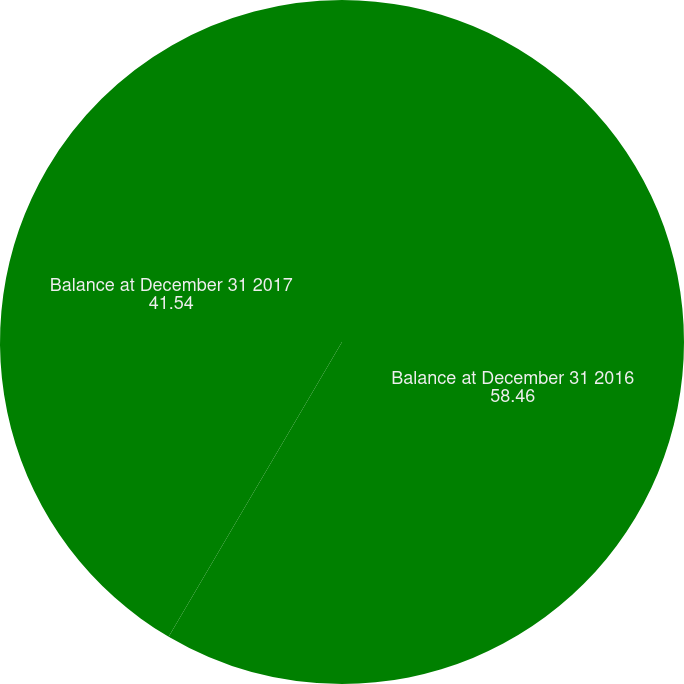<chart> <loc_0><loc_0><loc_500><loc_500><pie_chart><fcel>Balance at December 31 2016<fcel>Balance at December 31 2017<nl><fcel>58.46%<fcel>41.54%<nl></chart> 